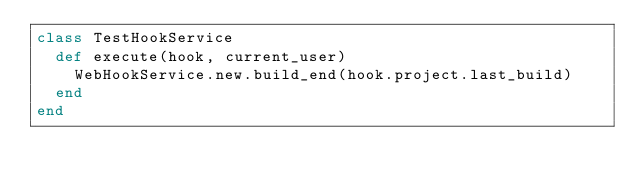Convert code to text. <code><loc_0><loc_0><loc_500><loc_500><_Ruby_>class TestHookService
  def execute(hook, current_user)
    WebHookService.new.build_end(hook.project.last_build)
  end
end
</code> 